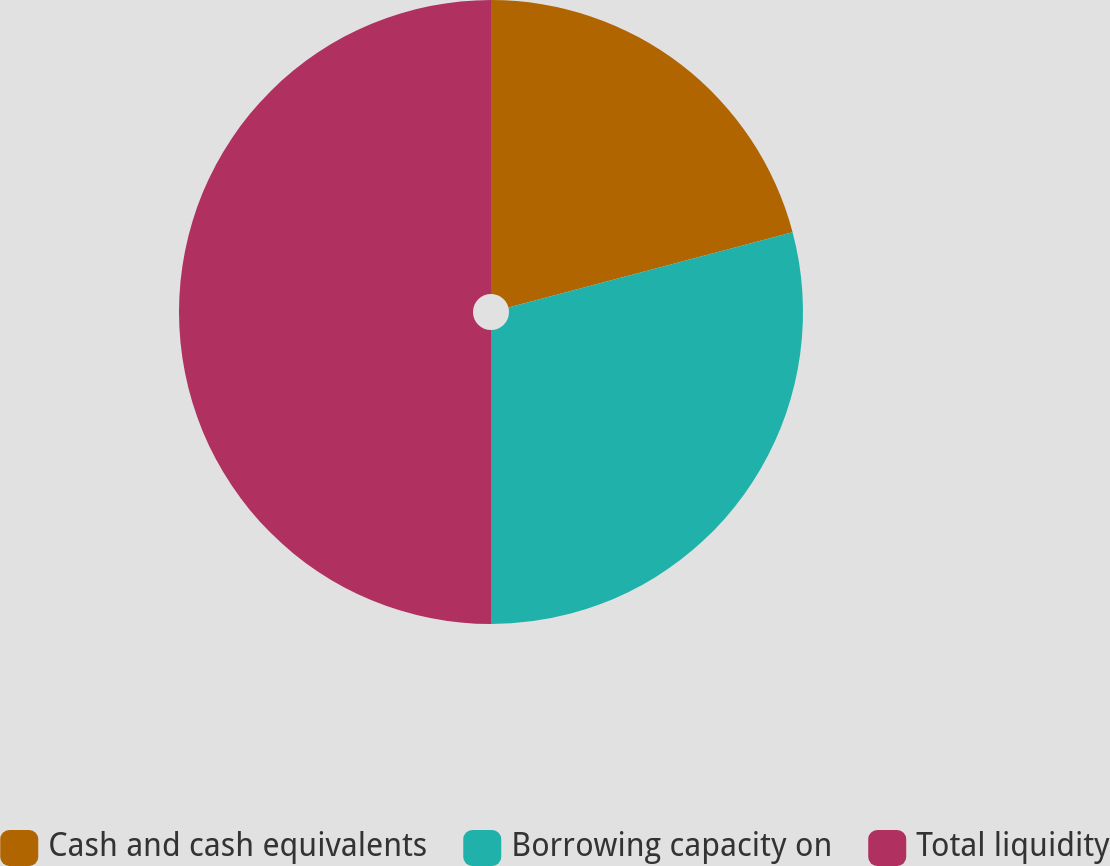Convert chart to OTSL. <chart><loc_0><loc_0><loc_500><loc_500><pie_chart><fcel>Cash and cash equivalents<fcel>Borrowing capacity on<fcel>Total liquidity<nl><fcel>20.88%<fcel>29.12%<fcel>50.0%<nl></chart> 